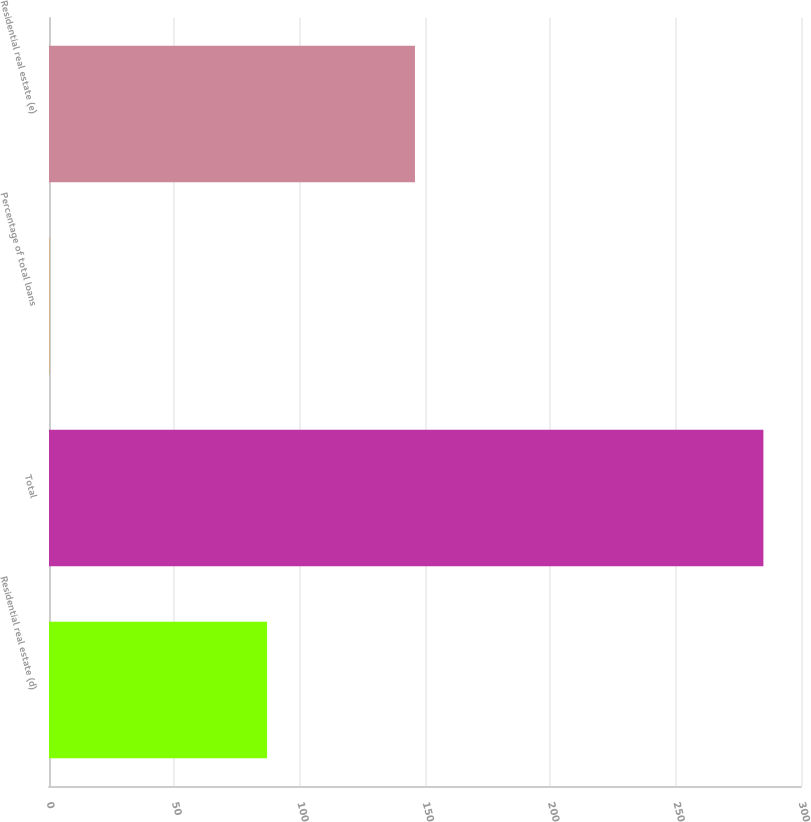Convert chart. <chart><loc_0><loc_0><loc_500><loc_500><bar_chart><fcel>Residential real estate (d)<fcel>Total<fcel>Percentage of total loans<fcel>Residential real estate (e)<nl><fcel>87<fcel>285<fcel>0.15<fcel>146<nl></chart> 